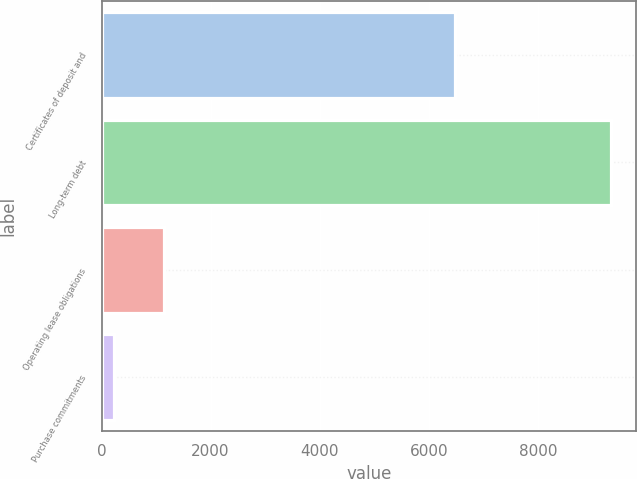<chart> <loc_0><loc_0><loc_500><loc_500><bar_chart><fcel>Certificates of deposit and<fcel>Long-term debt<fcel>Operating lease obligations<fcel>Purchase commitments<nl><fcel>6487<fcel>9335<fcel>1136.9<fcel>226<nl></chart> 